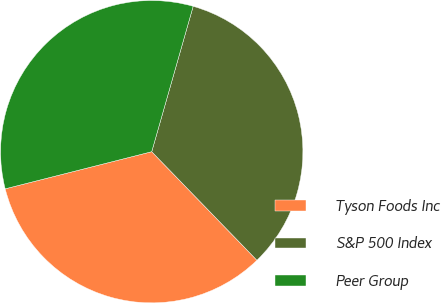Convert chart. <chart><loc_0><loc_0><loc_500><loc_500><pie_chart><fcel>Tyson Foods Inc<fcel>S&P 500 Index<fcel>Peer Group<nl><fcel>33.3%<fcel>33.33%<fcel>33.37%<nl></chart> 